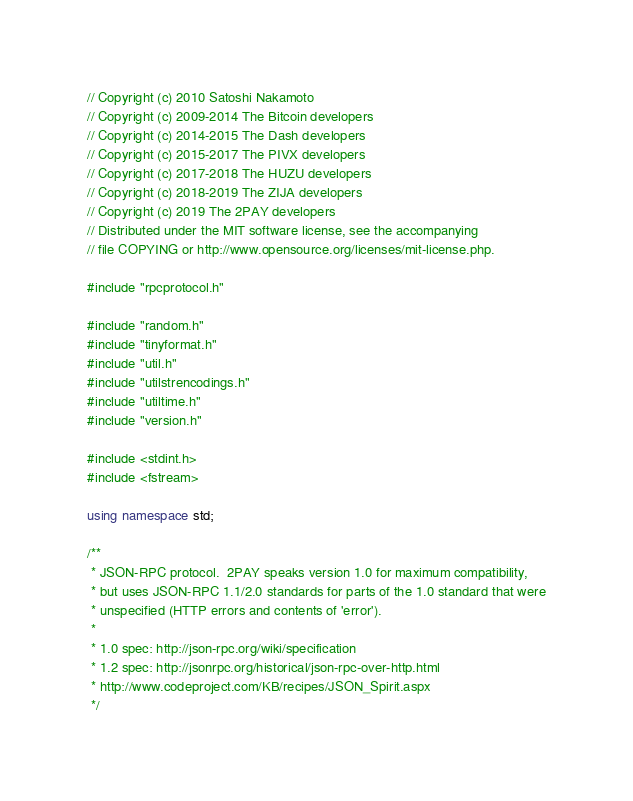<code> <loc_0><loc_0><loc_500><loc_500><_C++_>// Copyright (c) 2010 Satoshi Nakamoto
// Copyright (c) 2009-2014 The Bitcoin developers
// Copyright (c) 2014-2015 The Dash developers
// Copyright (c) 2015-2017 The PIVX developers
// Copyright (c) 2017-2018 The HUZU developers
// Copyright (c) 2018-2019 The ZIJA developers
// Copyright (c) 2019 The 2PAY developers
// Distributed under the MIT software license, see the accompanying
// file COPYING or http://www.opensource.org/licenses/mit-license.php.

#include "rpcprotocol.h"

#include "random.h"
#include "tinyformat.h"
#include "util.h"
#include "utilstrencodings.h"
#include "utiltime.h"
#include "version.h"

#include <stdint.h>
#include <fstream>

using namespace std;

/**
 * JSON-RPC protocol.  2PAY speaks version 1.0 for maximum compatibility,
 * but uses JSON-RPC 1.1/2.0 standards for parts of the 1.0 standard that were
 * unspecified (HTTP errors and contents of 'error').
 *
 * 1.0 spec: http://json-rpc.org/wiki/specification
 * 1.2 spec: http://jsonrpc.org/historical/json-rpc-over-http.html
 * http://www.codeproject.com/KB/recipes/JSON_Spirit.aspx
 */
</code> 